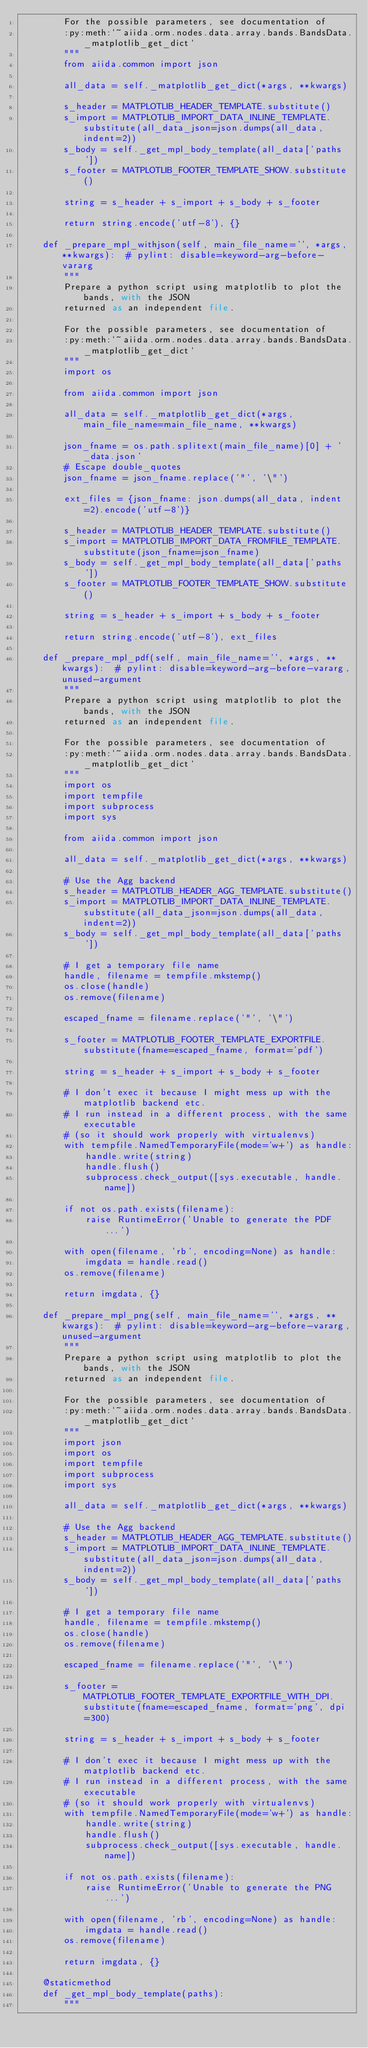Convert code to text. <code><loc_0><loc_0><loc_500><loc_500><_Python_>        For the possible parameters, see documentation of
        :py:meth:`~aiida.orm.nodes.data.array.bands.BandsData._matplotlib_get_dict`
        """
        from aiida.common import json

        all_data = self._matplotlib_get_dict(*args, **kwargs)

        s_header = MATPLOTLIB_HEADER_TEMPLATE.substitute()
        s_import = MATPLOTLIB_IMPORT_DATA_INLINE_TEMPLATE.substitute(all_data_json=json.dumps(all_data, indent=2))
        s_body = self._get_mpl_body_template(all_data['paths'])
        s_footer = MATPLOTLIB_FOOTER_TEMPLATE_SHOW.substitute()

        string = s_header + s_import + s_body + s_footer

        return string.encode('utf-8'), {}

    def _prepare_mpl_withjson(self, main_file_name='', *args, **kwargs):  # pylint: disable=keyword-arg-before-vararg
        """
        Prepare a python script using matplotlib to plot the bands, with the JSON
        returned as an independent file.

        For the possible parameters, see documentation of
        :py:meth:`~aiida.orm.nodes.data.array.bands.BandsData._matplotlib_get_dict`
        """
        import os

        from aiida.common import json

        all_data = self._matplotlib_get_dict(*args, main_file_name=main_file_name, **kwargs)

        json_fname = os.path.splitext(main_file_name)[0] + '_data.json'
        # Escape double_quotes
        json_fname = json_fname.replace('"', '\"')

        ext_files = {json_fname: json.dumps(all_data, indent=2).encode('utf-8')}

        s_header = MATPLOTLIB_HEADER_TEMPLATE.substitute()
        s_import = MATPLOTLIB_IMPORT_DATA_FROMFILE_TEMPLATE.substitute(json_fname=json_fname)
        s_body = self._get_mpl_body_template(all_data['paths'])
        s_footer = MATPLOTLIB_FOOTER_TEMPLATE_SHOW.substitute()

        string = s_header + s_import + s_body + s_footer

        return string.encode('utf-8'), ext_files

    def _prepare_mpl_pdf(self, main_file_name='', *args, **kwargs):  # pylint: disable=keyword-arg-before-vararg,unused-argument
        """
        Prepare a python script using matplotlib to plot the bands, with the JSON
        returned as an independent file.

        For the possible parameters, see documentation of
        :py:meth:`~aiida.orm.nodes.data.array.bands.BandsData._matplotlib_get_dict`
        """
        import os
        import tempfile
        import subprocess
        import sys

        from aiida.common import json

        all_data = self._matplotlib_get_dict(*args, **kwargs)

        # Use the Agg backend
        s_header = MATPLOTLIB_HEADER_AGG_TEMPLATE.substitute()
        s_import = MATPLOTLIB_IMPORT_DATA_INLINE_TEMPLATE.substitute(all_data_json=json.dumps(all_data, indent=2))
        s_body = self._get_mpl_body_template(all_data['paths'])

        # I get a temporary file name
        handle, filename = tempfile.mkstemp()
        os.close(handle)
        os.remove(filename)

        escaped_fname = filename.replace('"', '\"')

        s_footer = MATPLOTLIB_FOOTER_TEMPLATE_EXPORTFILE.substitute(fname=escaped_fname, format='pdf')

        string = s_header + s_import + s_body + s_footer

        # I don't exec it because I might mess up with the matplotlib backend etc.
        # I run instead in a different process, with the same executable
        # (so it should work properly with virtualenvs)
        with tempfile.NamedTemporaryFile(mode='w+') as handle:
            handle.write(string)
            handle.flush()
            subprocess.check_output([sys.executable, handle.name])

        if not os.path.exists(filename):
            raise RuntimeError('Unable to generate the PDF...')

        with open(filename, 'rb', encoding=None) as handle:
            imgdata = handle.read()
        os.remove(filename)

        return imgdata, {}

    def _prepare_mpl_png(self, main_file_name='', *args, **kwargs):  # pylint: disable=keyword-arg-before-vararg,unused-argument
        """
        Prepare a python script using matplotlib to plot the bands, with the JSON
        returned as an independent file.

        For the possible parameters, see documentation of
        :py:meth:`~aiida.orm.nodes.data.array.bands.BandsData._matplotlib_get_dict`
        """
        import json
        import os
        import tempfile
        import subprocess
        import sys

        all_data = self._matplotlib_get_dict(*args, **kwargs)

        # Use the Agg backend
        s_header = MATPLOTLIB_HEADER_AGG_TEMPLATE.substitute()
        s_import = MATPLOTLIB_IMPORT_DATA_INLINE_TEMPLATE.substitute(all_data_json=json.dumps(all_data, indent=2))
        s_body = self._get_mpl_body_template(all_data['paths'])

        # I get a temporary file name
        handle, filename = tempfile.mkstemp()
        os.close(handle)
        os.remove(filename)

        escaped_fname = filename.replace('"', '\"')

        s_footer = MATPLOTLIB_FOOTER_TEMPLATE_EXPORTFILE_WITH_DPI.substitute(fname=escaped_fname, format='png', dpi=300)

        string = s_header + s_import + s_body + s_footer

        # I don't exec it because I might mess up with the matplotlib backend etc.
        # I run instead in a different process, with the same executable
        # (so it should work properly with virtualenvs)
        with tempfile.NamedTemporaryFile(mode='w+') as handle:
            handle.write(string)
            handle.flush()
            subprocess.check_output([sys.executable, handle.name])

        if not os.path.exists(filename):
            raise RuntimeError('Unable to generate the PNG...')

        with open(filename, 'rb', encoding=None) as handle:
            imgdata = handle.read()
        os.remove(filename)

        return imgdata, {}

    @staticmethod
    def _get_mpl_body_template(paths):
        """</code> 